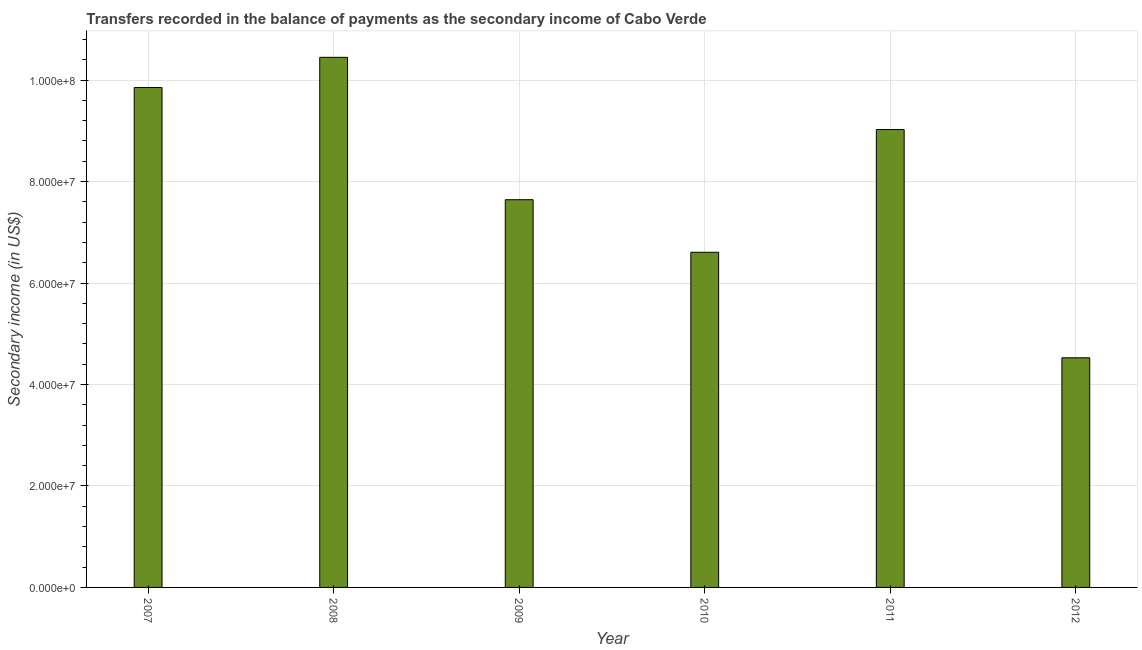What is the title of the graph?
Provide a short and direct response. Transfers recorded in the balance of payments as the secondary income of Cabo Verde. What is the label or title of the X-axis?
Provide a succinct answer. Year. What is the label or title of the Y-axis?
Give a very brief answer. Secondary income (in US$). What is the amount of secondary income in 2009?
Your answer should be very brief. 7.64e+07. Across all years, what is the maximum amount of secondary income?
Your answer should be very brief. 1.04e+08. Across all years, what is the minimum amount of secondary income?
Keep it short and to the point. 4.53e+07. In which year was the amount of secondary income minimum?
Your response must be concise. 2012. What is the sum of the amount of secondary income?
Keep it short and to the point. 4.81e+08. What is the difference between the amount of secondary income in 2010 and 2012?
Your answer should be very brief. 2.08e+07. What is the average amount of secondary income per year?
Offer a terse response. 8.02e+07. What is the median amount of secondary income?
Offer a very short reply. 8.33e+07. Do a majority of the years between 2008 and 2009 (inclusive) have amount of secondary income greater than 56000000 US$?
Your answer should be compact. Yes. What is the ratio of the amount of secondary income in 2010 to that in 2012?
Offer a very short reply. 1.46. Is the amount of secondary income in 2010 less than that in 2012?
Your answer should be compact. No. Is the difference between the amount of secondary income in 2008 and 2011 greater than the difference between any two years?
Keep it short and to the point. No. What is the difference between the highest and the second highest amount of secondary income?
Give a very brief answer. 5.95e+06. What is the difference between the highest and the lowest amount of secondary income?
Give a very brief answer. 5.92e+07. In how many years, is the amount of secondary income greater than the average amount of secondary income taken over all years?
Keep it short and to the point. 3. How many bars are there?
Provide a short and direct response. 6. What is the Secondary income (in US$) in 2007?
Offer a very short reply. 9.85e+07. What is the Secondary income (in US$) in 2008?
Provide a short and direct response. 1.04e+08. What is the Secondary income (in US$) in 2009?
Keep it short and to the point. 7.64e+07. What is the Secondary income (in US$) of 2010?
Your answer should be very brief. 6.61e+07. What is the Secondary income (in US$) in 2011?
Offer a very short reply. 9.03e+07. What is the Secondary income (in US$) in 2012?
Keep it short and to the point. 4.53e+07. What is the difference between the Secondary income (in US$) in 2007 and 2008?
Make the answer very short. -5.95e+06. What is the difference between the Secondary income (in US$) in 2007 and 2009?
Ensure brevity in your answer.  2.21e+07. What is the difference between the Secondary income (in US$) in 2007 and 2010?
Provide a succinct answer. 3.25e+07. What is the difference between the Secondary income (in US$) in 2007 and 2011?
Offer a terse response. 8.28e+06. What is the difference between the Secondary income (in US$) in 2007 and 2012?
Provide a succinct answer. 5.33e+07. What is the difference between the Secondary income (in US$) in 2008 and 2009?
Give a very brief answer. 2.81e+07. What is the difference between the Secondary income (in US$) in 2008 and 2010?
Make the answer very short. 3.84e+07. What is the difference between the Secondary income (in US$) in 2008 and 2011?
Provide a short and direct response. 1.42e+07. What is the difference between the Secondary income (in US$) in 2008 and 2012?
Your answer should be compact. 5.92e+07. What is the difference between the Secondary income (in US$) in 2009 and 2010?
Keep it short and to the point. 1.04e+07. What is the difference between the Secondary income (in US$) in 2009 and 2011?
Offer a terse response. -1.38e+07. What is the difference between the Secondary income (in US$) in 2009 and 2012?
Keep it short and to the point. 3.12e+07. What is the difference between the Secondary income (in US$) in 2010 and 2011?
Give a very brief answer. -2.42e+07. What is the difference between the Secondary income (in US$) in 2010 and 2012?
Make the answer very short. 2.08e+07. What is the difference between the Secondary income (in US$) in 2011 and 2012?
Your answer should be compact. 4.50e+07. What is the ratio of the Secondary income (in US$) in 2007 to that in 2008?
Give a very brief answer. 0.94. What is the ratio of the Secondary income (in US$) in 2007 to that in 2009?
Your response must be concise. 1.29. What is the ratio of the Secondary income (in US$) in 2007 to that in 2010?
Offer a very short reply. 1.49. What is the ratio of the Secondary income (in US$) in 2007 to that in 2011?
Offer a terse response. 1.09. What is the ratio of the Secondary income (in US$) in 2007 to that in 2012?
Ensure brevity in your answer.  2.18. What is the ratio of the Secondary income (in US$) in 2008 to that in 2009?
Provide a short and direct response. 1.37. What is the ratio of the Secondary income (in US$) in 2008 to that in 2010?
Provide a short and direct response. 1.58. What is the ratio of the Secondary income (in US$) in 2008 to that in 2011?
Offer a very short reply. 1.16. What is the ratio of the Secondary income (in US$) in 2008 to that in 2012?
Provide a succinct answer. 2.31. What is the ratio of the Secondary income (in US$) in 2009 to that in 2010?
Your response must be concise. 1.16. What is the ratio of the Secondary income (in US$) in 2009 to that in 2011?
Your answer should be very brief. 0.85. What is the ratio of the Secondary income (in US$) in 2009 to that in 2012?
Make the answer very short. 1.69. What is the ratio of the Secondary income (in US$) in 2010 to that in 2011?
Keep it short and to the point. 0.73. What is the ratio of the Secondary income (in US$) in 2010 to that in 2012?
Give a very brief answer. 1.46. What is the ratio of the Secondary income (in US$) in 2011 to that in 2012?
Give a very brief answer. 1.99. 